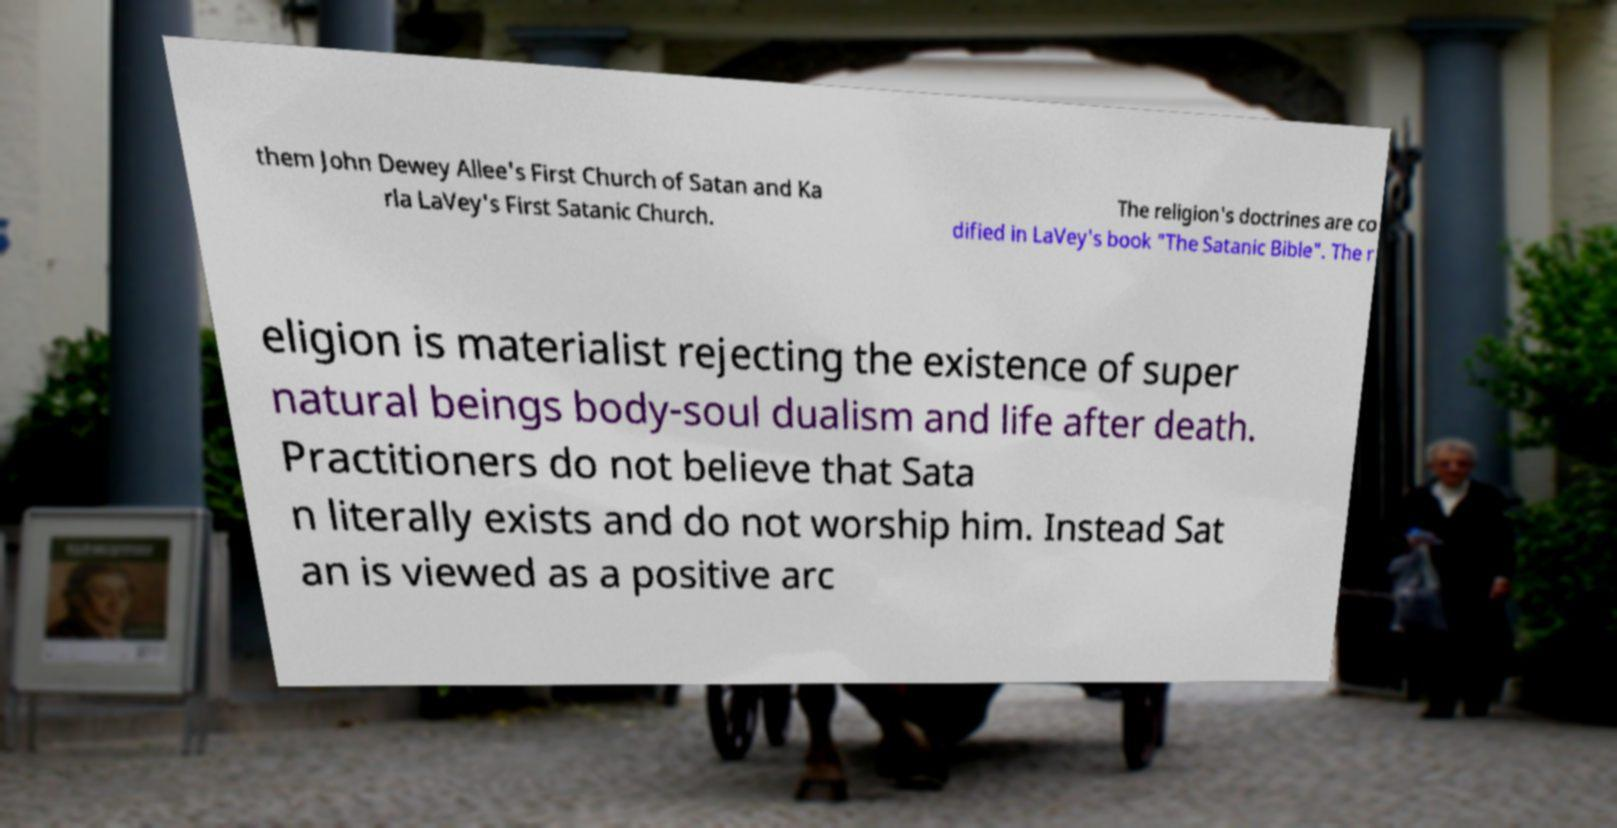There's text embedded in this image that I need extracted. Can you transcribe it verbatim? them John Dewey Allee's First Church of Satan and Ka rla LaVey's First Satanic Church. The religion's doctrines are co dified in LaVey's book "The Satanic Bible". The r eligion is materialist rejecting the existence of super natural beings body-soul dualism and life after death. Practitioners do not believe that Sata n literally exists and do not worship him. Instead Sat an is viewed as a positive arc 